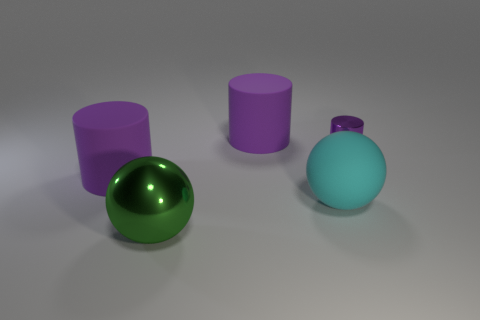Is the number of big purple cylinders that are to the right of the cyan sphere less than the number of green shiny objects? Indeed, the number of large purple cylinders situated to the right of the cyan sphere is less than the number of objects that are of a green, shiny appearance. To be more precise, there is only one big purple cylinder to the right of the cyan sphere, while there appears to be a single green shiny sphere present in the image. 